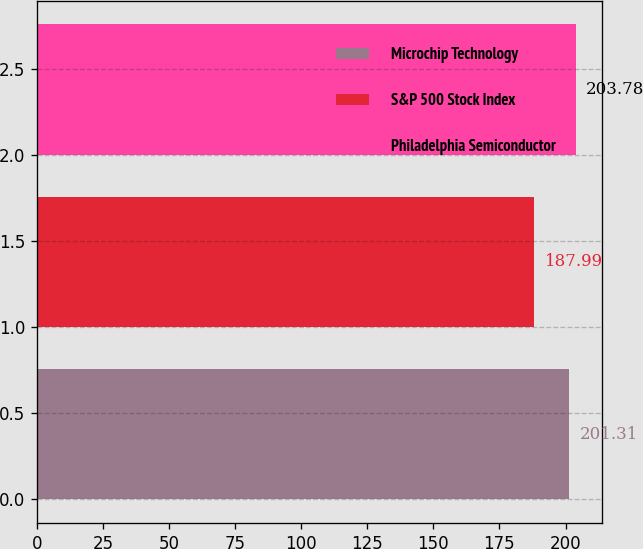Convert chart. <chart><loc_0><loc_0><loc_500><loc_500><bar_chart><fcel>Microchip Technology<fcel>S&P 500 Stock Index<fcel>Philadelphia Semiconductor<nl><fcel>201.31<fcel>187.99<fcel>203.78<nl></chart> 